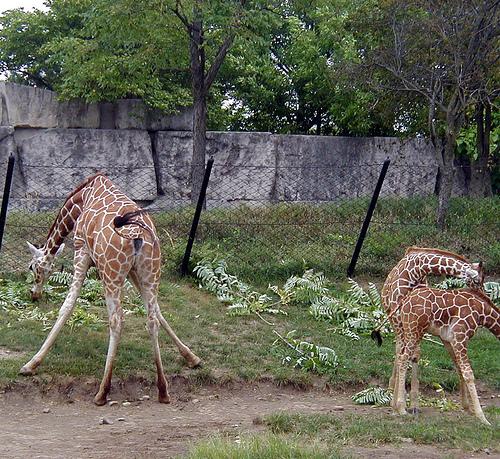How many animals are there?
Short answer required. 2. Are the giraffes looking up or down?
Short answer required. Down. Are these animals shown in the wild?
Keep it brief. No. Do these animals appear free to roam?
Write a very short answer. No. What kind of animal are these?
Be succinct. Giraffe. 